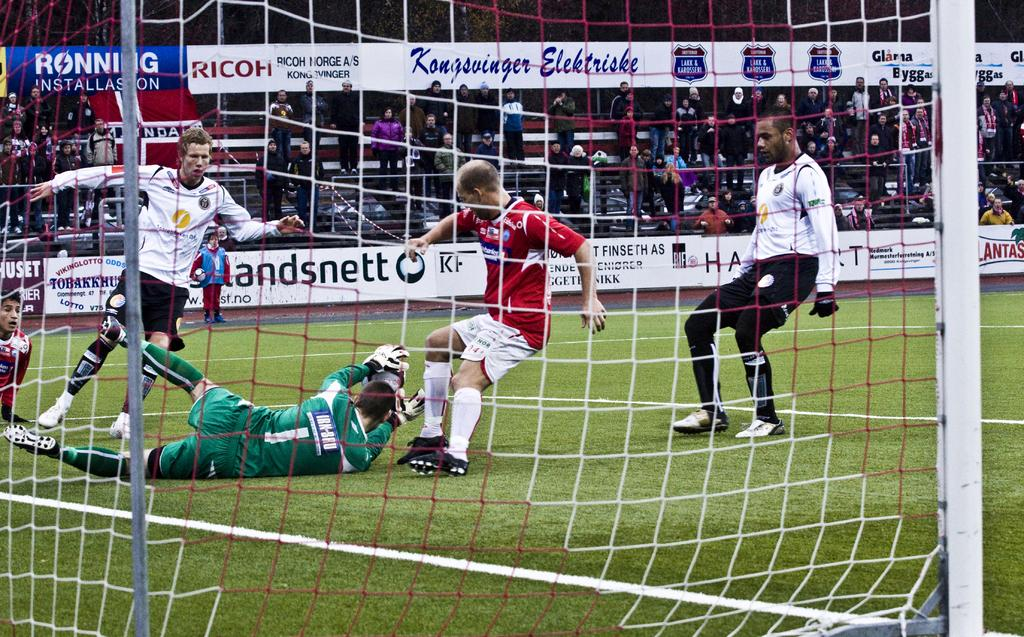<image>
Create a compact narrative representing the image presented. Players race towards the goal with the ball near a RICOH ad 